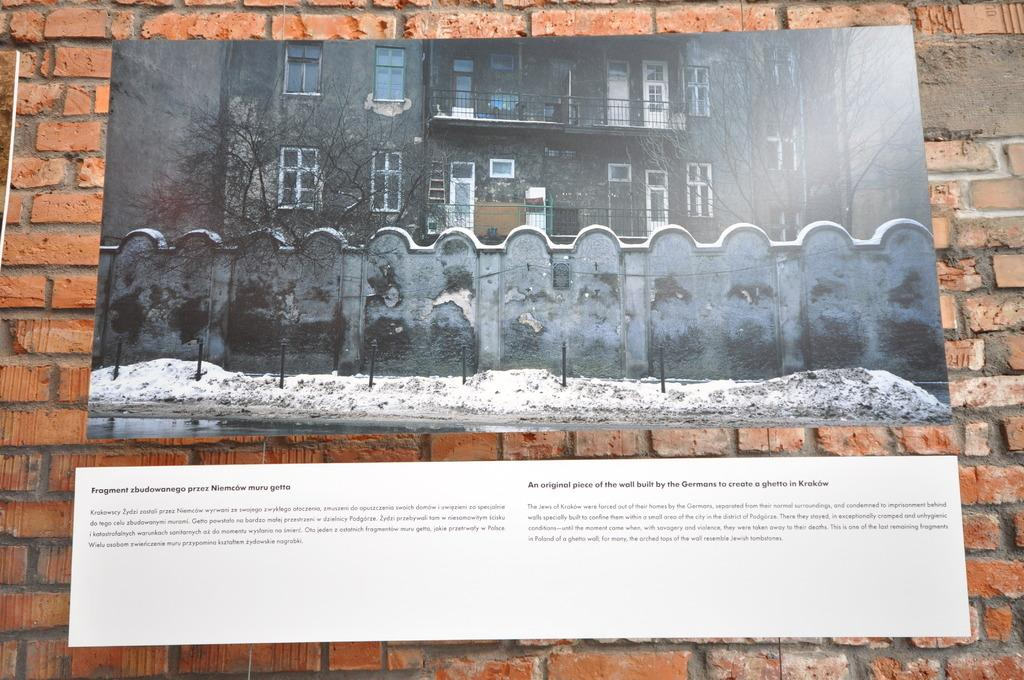What type of material is used to construct the wall in the image? The wall in the image is made of red bricks. What is displayed on the boards attached to the wall? The boards on the wall have pictures and text. What can be seen in the background of the image? Buildings and trees are visible in the image. How many walls are visible in the image? There are at least two walls visible in the image. What is the condition of the ground in the image? Snow is present on the ground in the image. Where is the faucet located in the image? There is no faucet present in the image. What direction are the trees facing in the image? Trees do not face a specific direction; they are stationary plants. 